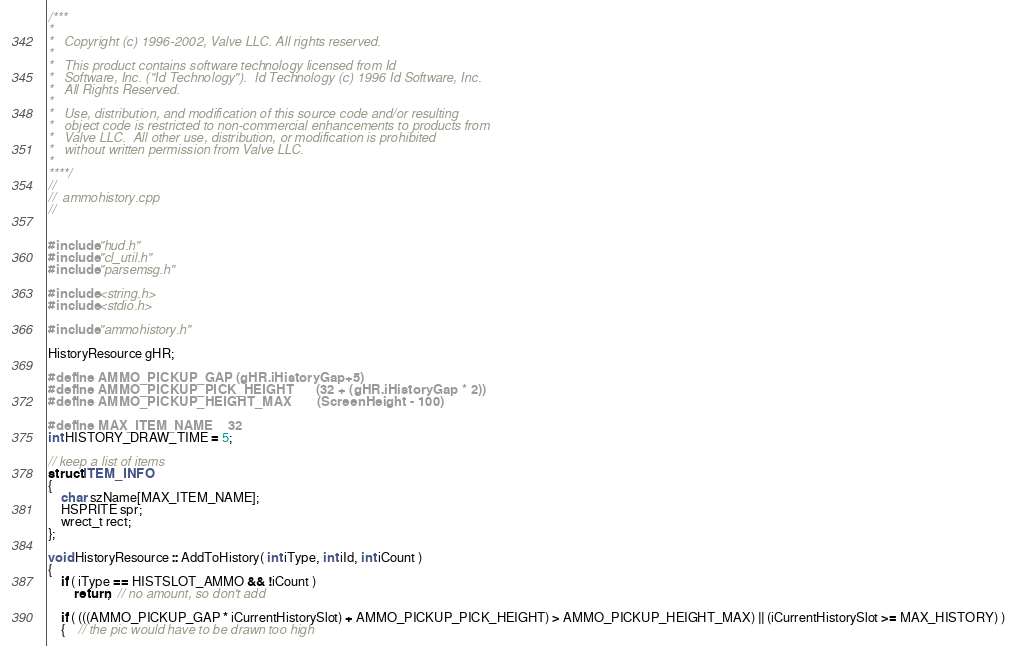<code> <loc_0><loc_0><loc_500><loc_500><_C++_>/***
*
*	Copyright (c) 1996-2002, Valve LLC. All rights reserved.
*	
*	This product contains software technology licensed from Id 
*	Software, Inc. ("Id Technology").  Id Technology (c) 1996 Id Software, Inc. 
*	All Rights Reserved.
*
*   Use, distribution, and modification of this source code and/or resulting
*   object code is restricted to non-commercial enhancements to products from
*   Valve LLC.  All other use, distribution, or modification is prohibited
*   without written permission from Valve LLC.
*
****/
//
//  ammohistory.cpp
//


#include "hud.h"
#include "cl_util.h"
#include "parsemsg.h"

#include <string.h>
#include <stdio.h>

#include "ammohistory.h"

HistoryResource gHR;

#define AMMO_PICKUP_GAP (gHR.iHistoryGap+5)
#define AMMO_PICKUP_PICK_HEIGHT		(32 + (gHR.iHistoryGap * 2))
#define AMMO_PICKUP_HEIGHT_MAX		(ScreenHeight - 100)

#define MAX_ITEM_NAME	32
int HISTORY_DRAW_TIME = 5;

// keep a list of items
struct ITEM_INFO
{
	char szName[MAX_ITEM_NAME];
	HSPRITE spr;
	wrect_t rect;
};

void HistoryResource :: AddToHistory( int iType, int iId, int iCount )
{
	if ( iType == HISTSLOT_AMMO && !iCount )
		return;  // no amount, so don't add

	if ( (((AMMO_PICKUP_GAP * iCurrentHistorySlot) + AMMO_PICKUP_PICK_HEIGHT) > AMMO_PICKUP_HEIGHT_MAX) || (iCurrentHistorySlot >= MAX_HISTORY) )
	{	// the pic would have to be drawn too high</code> 